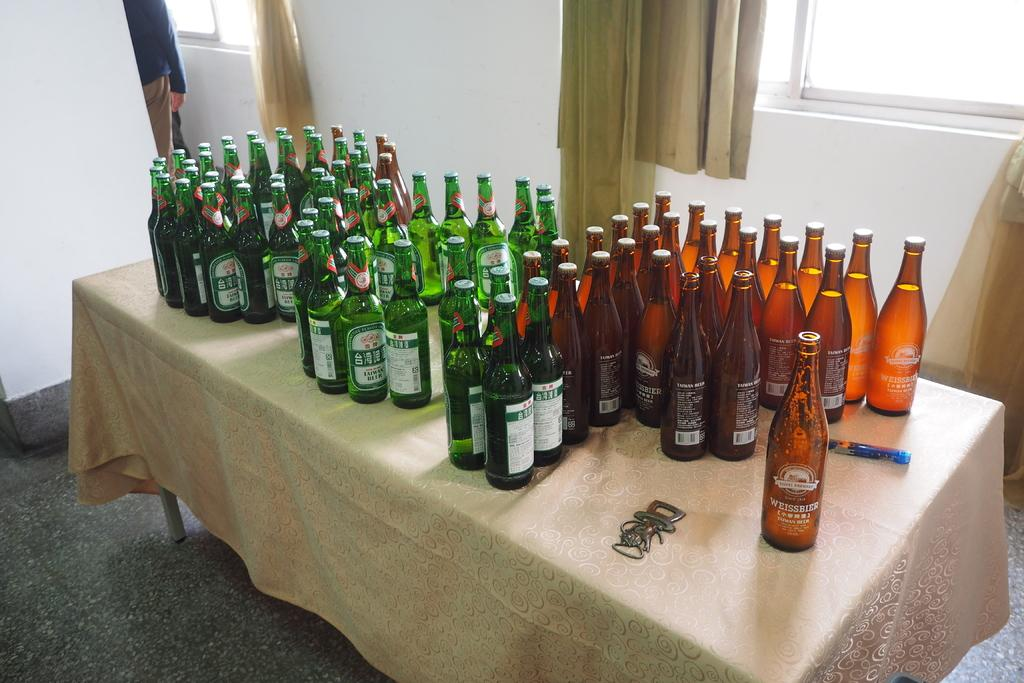<image>
Offer a succinct explanation of the picture presented. A table is covered with Taiwan beer bottles 